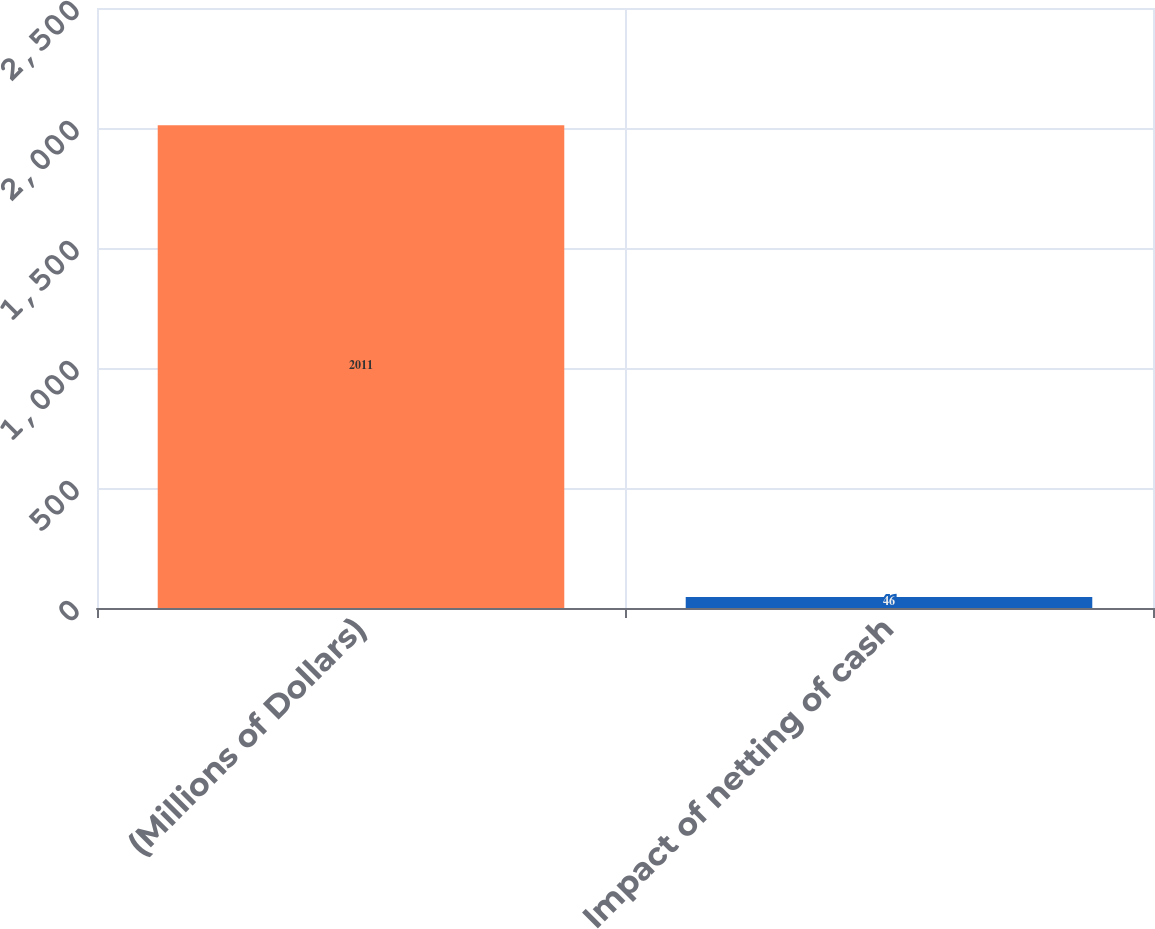Convert chart to OTSL. <chart><loc_0><loc_0><loc_500><loc_500><bar_chart><fcel>(Millions of Dollars)<fcel>Impact of netting of cash<nl><fcel>2011<fcel>46<nl></chart> 